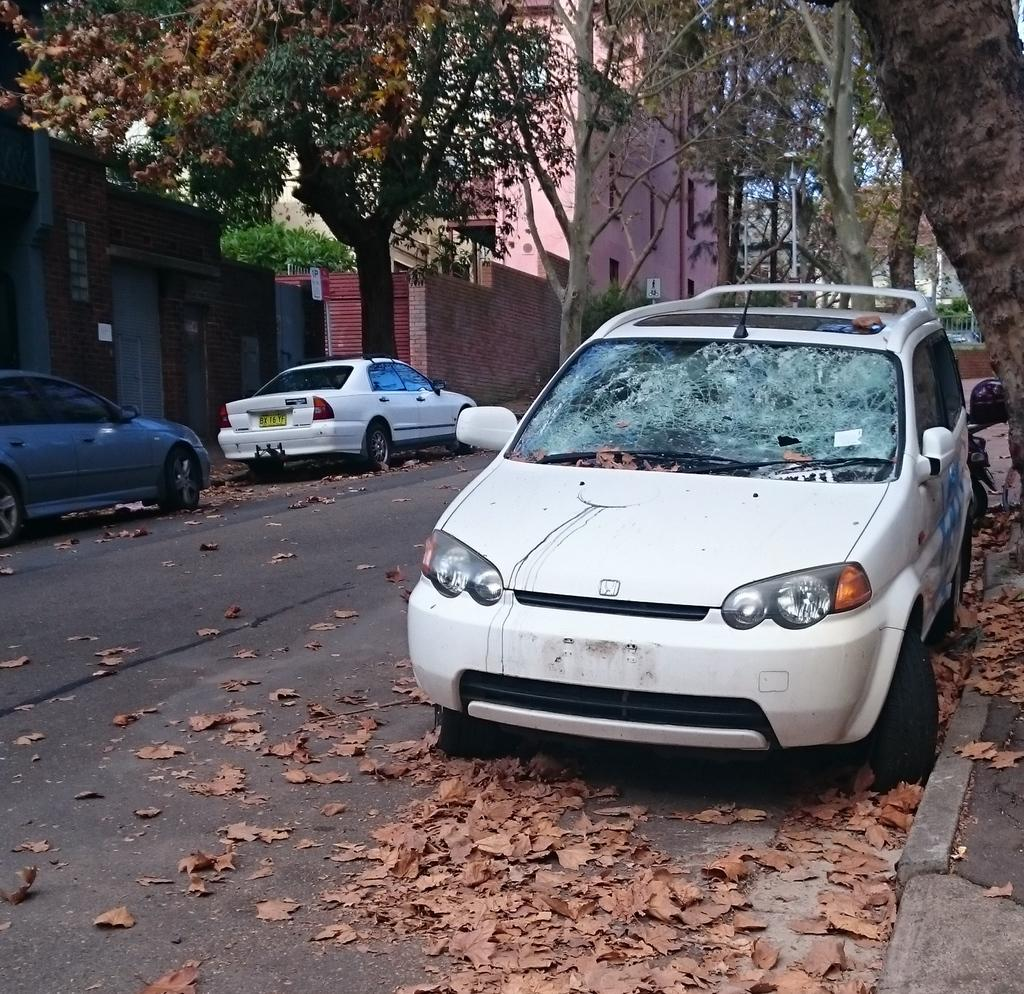What types of vehicles can be seen in the image? There are different colors of cars in the image. What else is present on the ground in the image besides cars? Dry leaves are present in the image. What type of natural elements can be seen in the image? There are trees in the image. What type of man-made structures can be seen in the image? There are buildings in the image. What type of pot is being used to increase the height of the board in the image? There is no pot, increase, or board present in the image. 